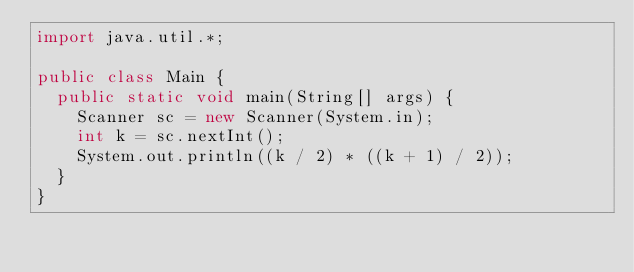<code> <loc_0><loc_0><loc_500><loc_500><_Java_>import java.util.*;

public class Main {
  public static void main(String[] args) {
    Scanner sc = new Scanner(System.in);
    int k = sc.nextInt();
    System.out.println((k / 2) * ((k + 1) / 2));
  }
}</code> 